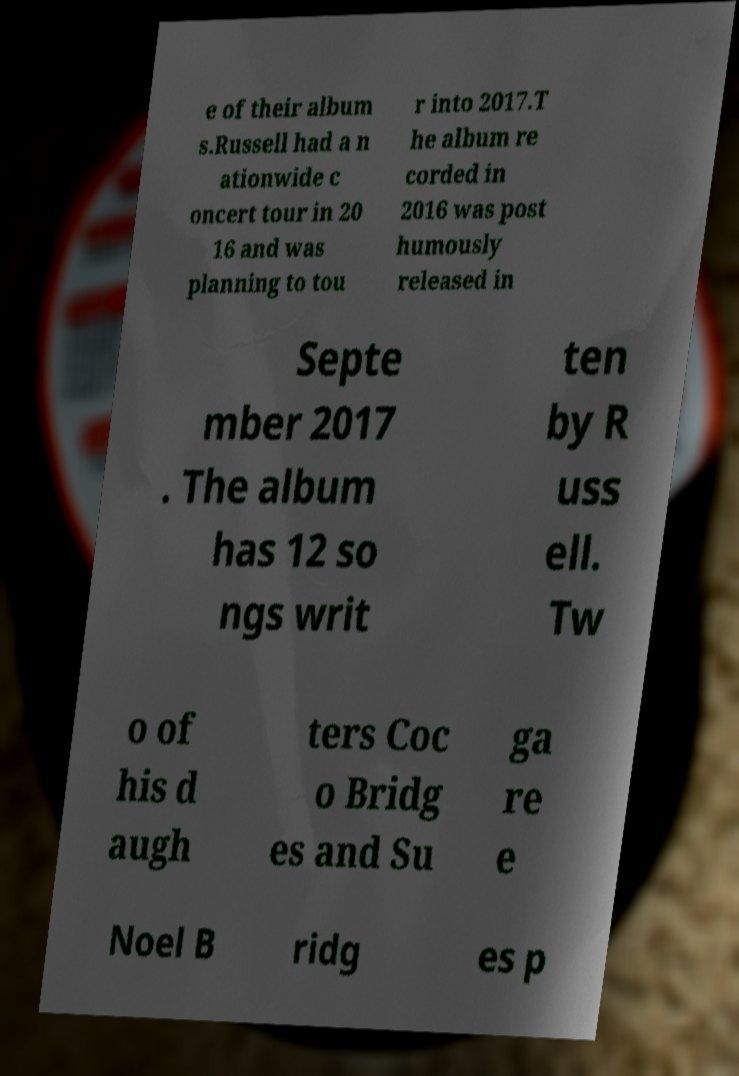What messages or text are displayed in this image? I need them in a readable, typed format. e of their album s.Russell had a n ationwide c oncert tour in 20 16 and was planning to tou r into 2017.T he album re corded in 2016 was post humously released in Septe mber 2017 . The album has 12 so ngs writ ten by R uss ell. Tw o of his d augh ters Coc o Bridg es and Su ga re e Noel B ridg es p 